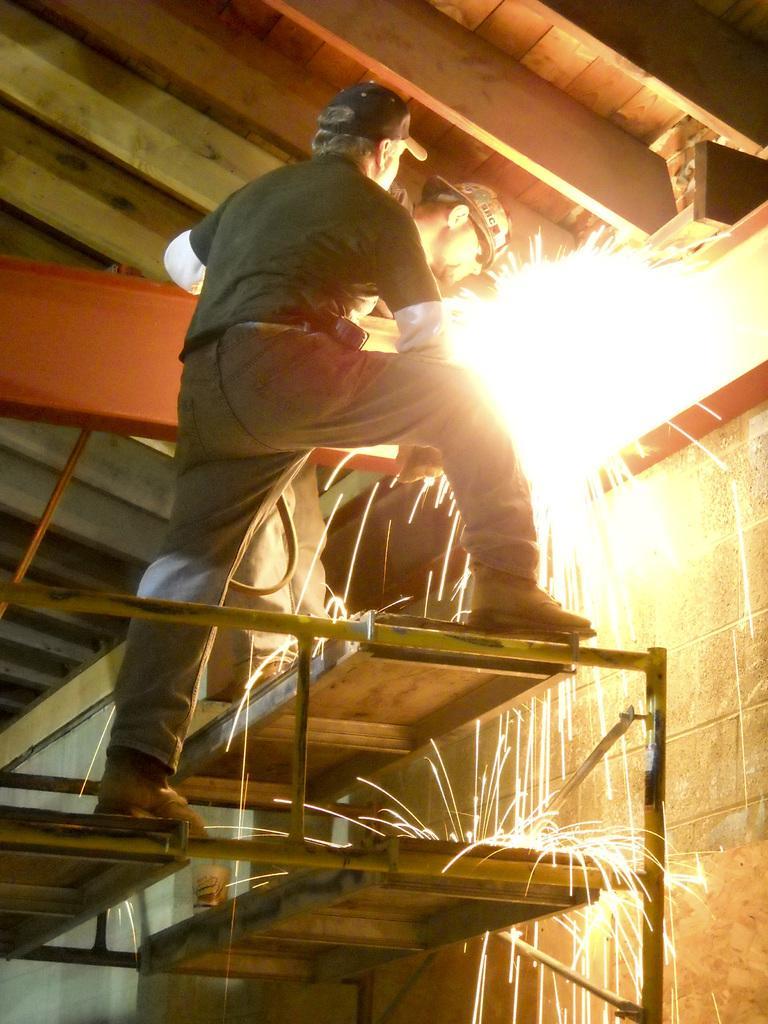In one or two sentences, can you explain what this image depicts? In this picture we can see two people, fire, wall, roof and some objects. 